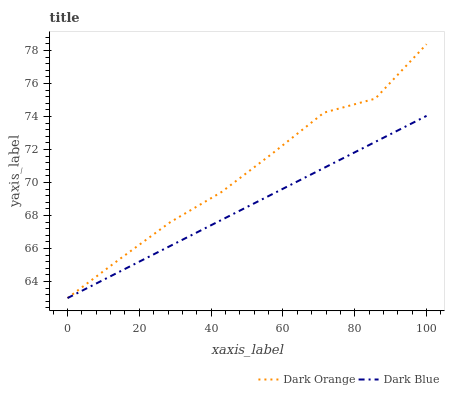Does Dark Blue have the maximum area under the curve?
Answer yes or no. No. Is Dark Blue the roughest?
Answer yes or no. No. Does Dark Blue have the highest value?
Answer yes or no. No. 